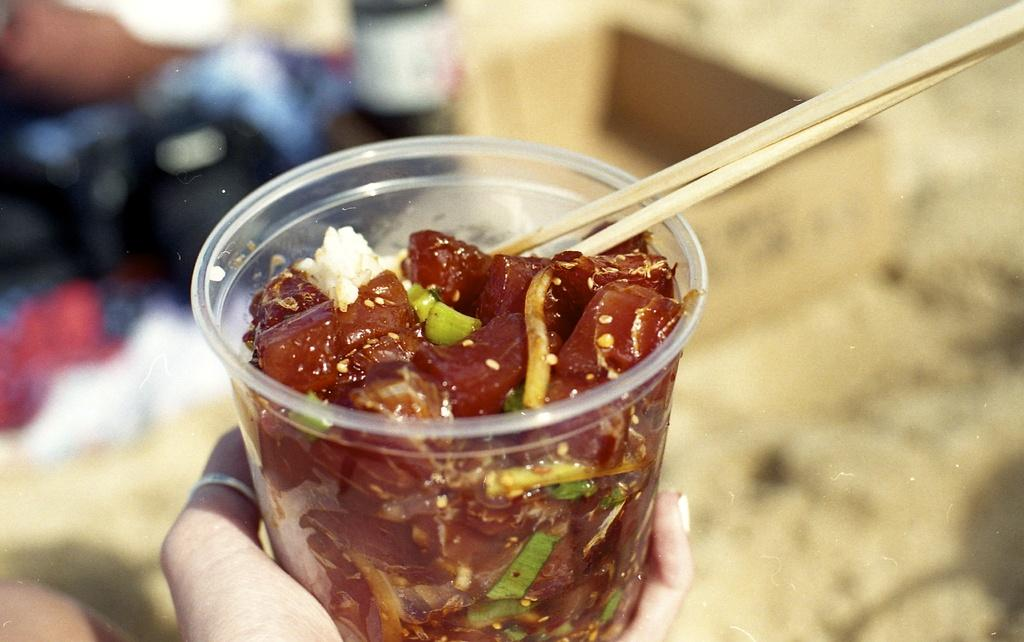What is the main subject of the image? There is a human hand in the image. What is the hand holding? The hand is holding a cup. What is inside the cup? There is food inside the cup. What other objects are present in the image? There are two sticks in the image. What is the tendency of the fifth object in the image? There is no fifth object present in the image, so it is not possible to determine its tendency. 